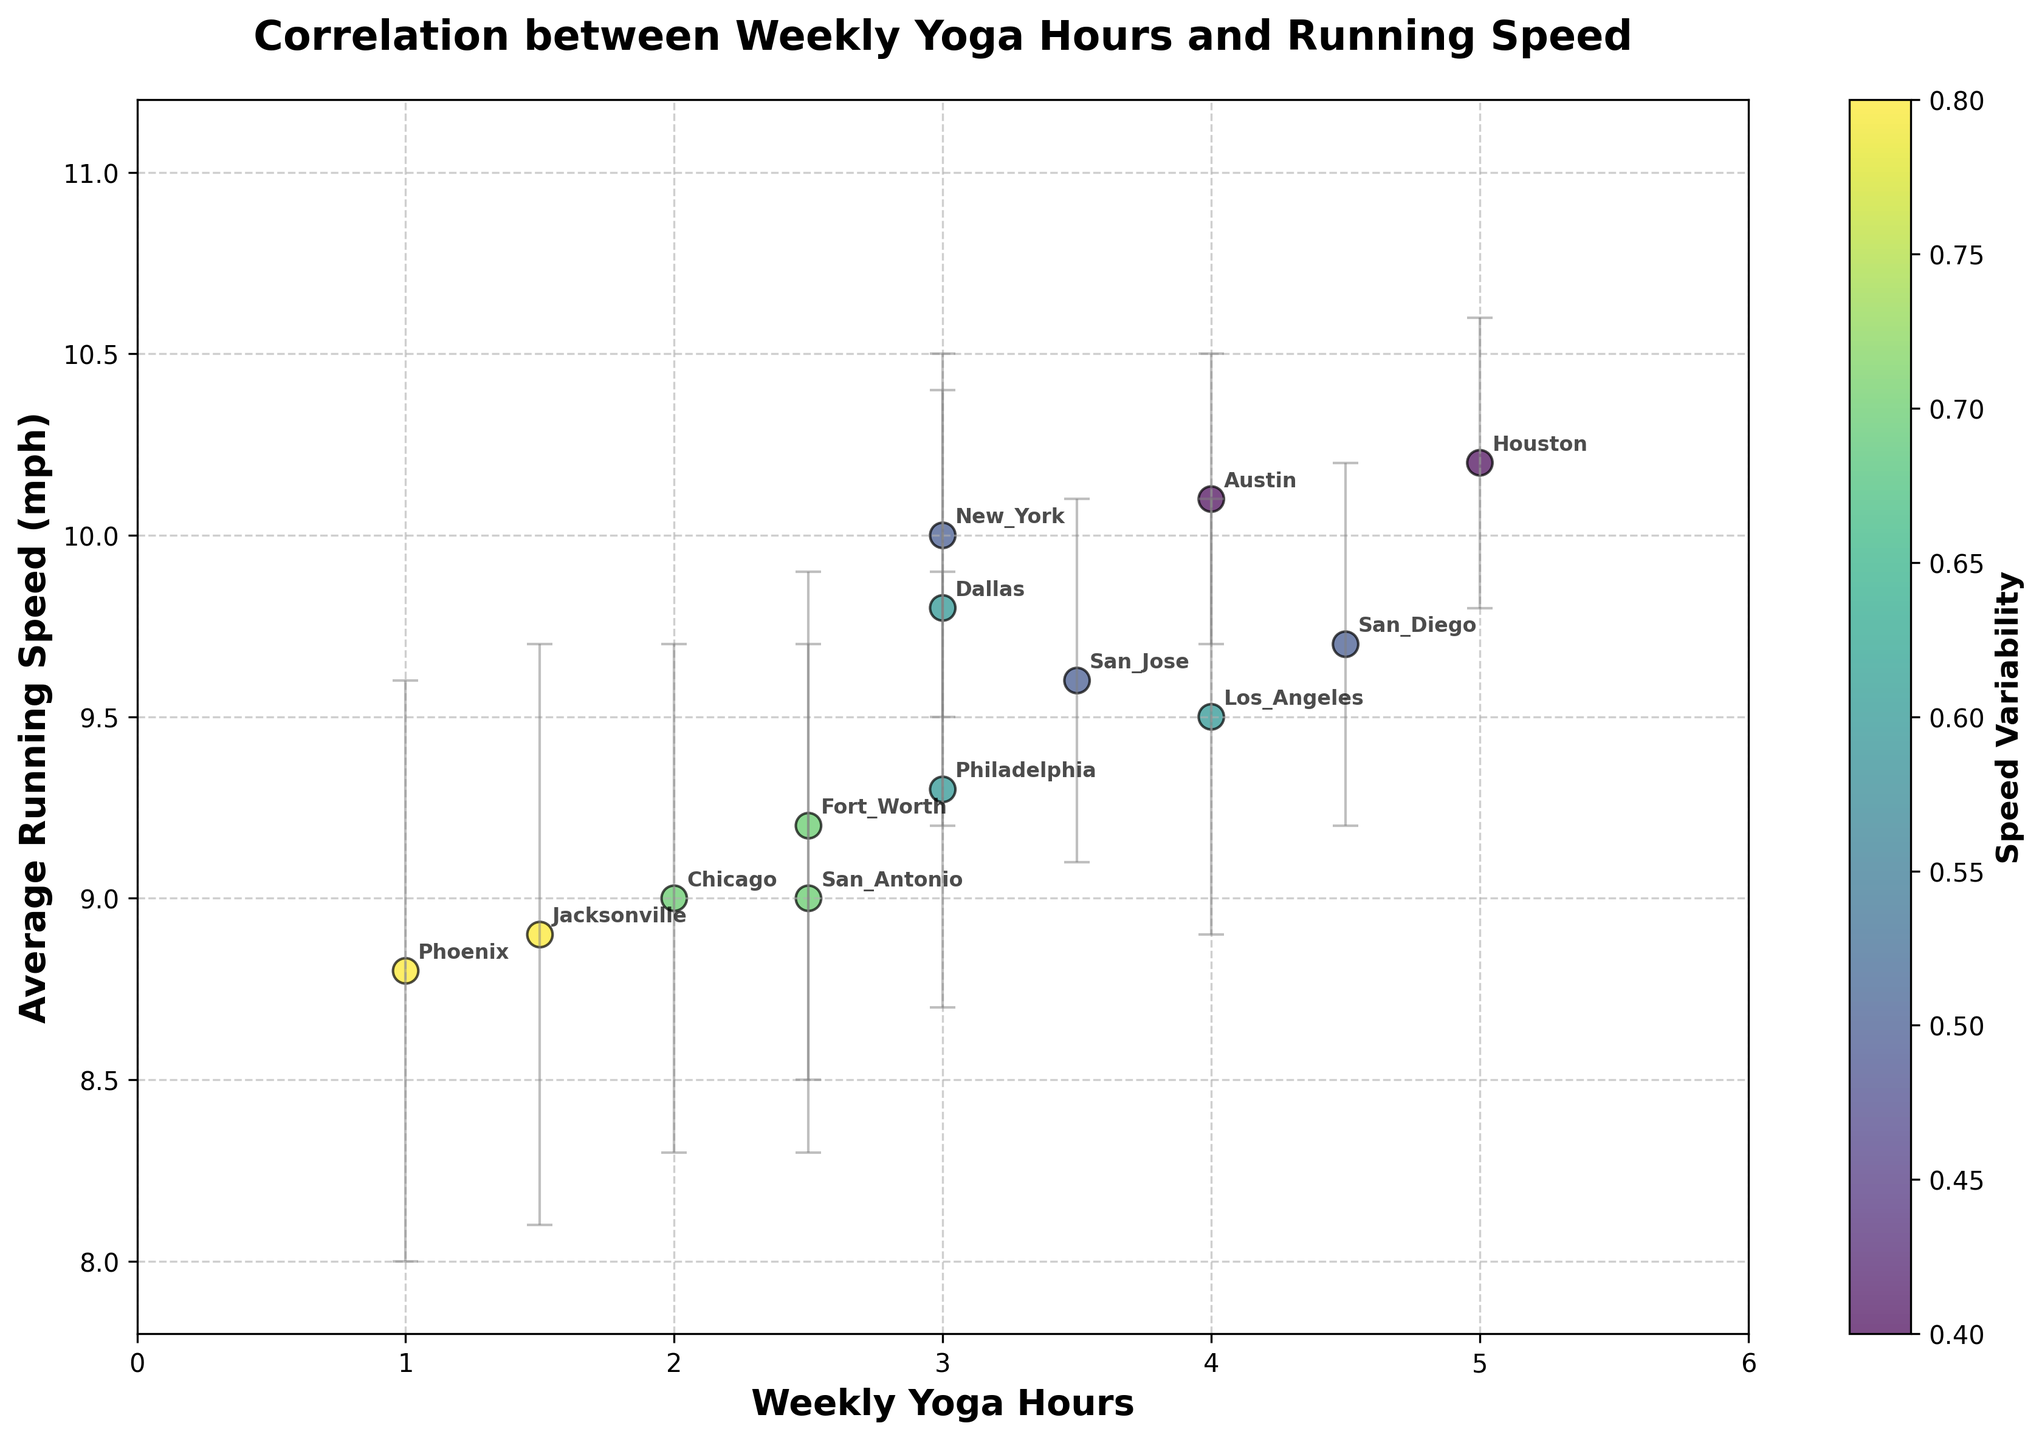what is the title of the chart? The title is located at the top of the chart and provides a summary of the visualized data
Answer: Correlation between Weekly Yoga Hours and Running Speed Which location has the highest average running speed? Locate the highest y-value on the chart, check which data point corresponds to it, and refer to the annotations for the location
Answer: Houston What is the range of weekly yoga hours represented in the chart? Check the x-axis and identify the lowest and highest values of weekly yoga hours
Answer: 1 to 5 hours which location exhibits the highest variability in average running speed? Observe the error bars for each data point and look for the longest error bar
Answer: Phoenix and Jacksonville (both 0.8) How many locations on the chart have average running speed greater than 10 mph? Identify data points positioned above 10 on the y-axis and count them
Answer: 3 locations What is the overall trend between weekly yoga hours and running speed? Observe the general direction of the data points, higher weekly yoga hours correlated with higher running speeds
Answer: Positive Correlation Which location has the lowest average running speed? Look for the data point with the lowest y-value and match it with its corresponding annotation
Answer: Phoenix Compare the average running speed of Dallas and Philadelphia. Which one is larger? Identify and compare the y-values for Dallas and Philadelphia, located at 3 and 3 weekly yoga hours respectively
Answer: Dallas (9.8) is larger than Philadelphia (9.3) On average, how does running speed change from 1 to 4 weekly yoga hours? Compare the average running speeds at 1 hour and 4 hours by finding their respective values and calculating the difference
Answer: The speed improves from 8.8 to around 10 mph, showing an increase Explain the color coding in the scatter plot. Each dot's color indicates speed variability, with the gradient revealed by the color bar to the right of the chart, showing levels of variability
Answer: Color represents speed variability 